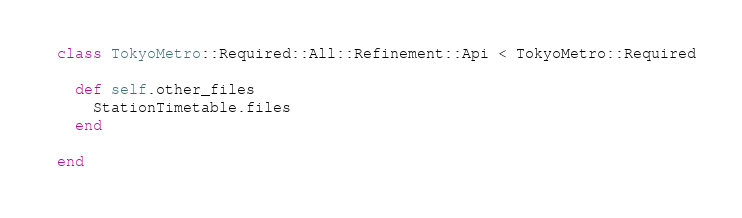Convert code to text. <code><loc_0><loc_0><loc_500><loc_500><_Ruby_>class TokyoMetro::Required::All::Refinement::Api < TokyoMetro::Required

  def self.other_files
    StationTimetable.files
  end

end</code> 